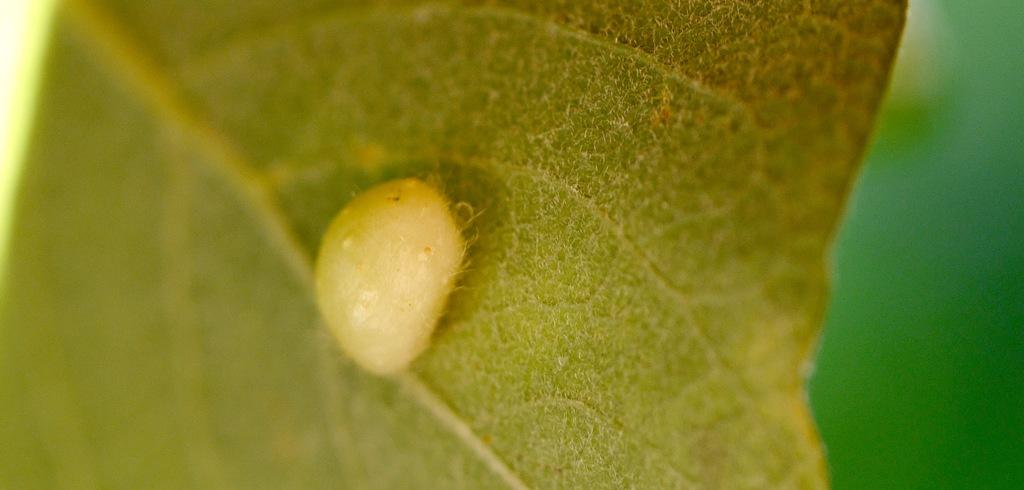What is the color of the object in the image? The object in the image is white. Where is the object located in the image? The object is on a leaf. What is the level of disgust felt by the object in the image? There is no indication of emotion or feeling in the image, as the object is inanimate. 